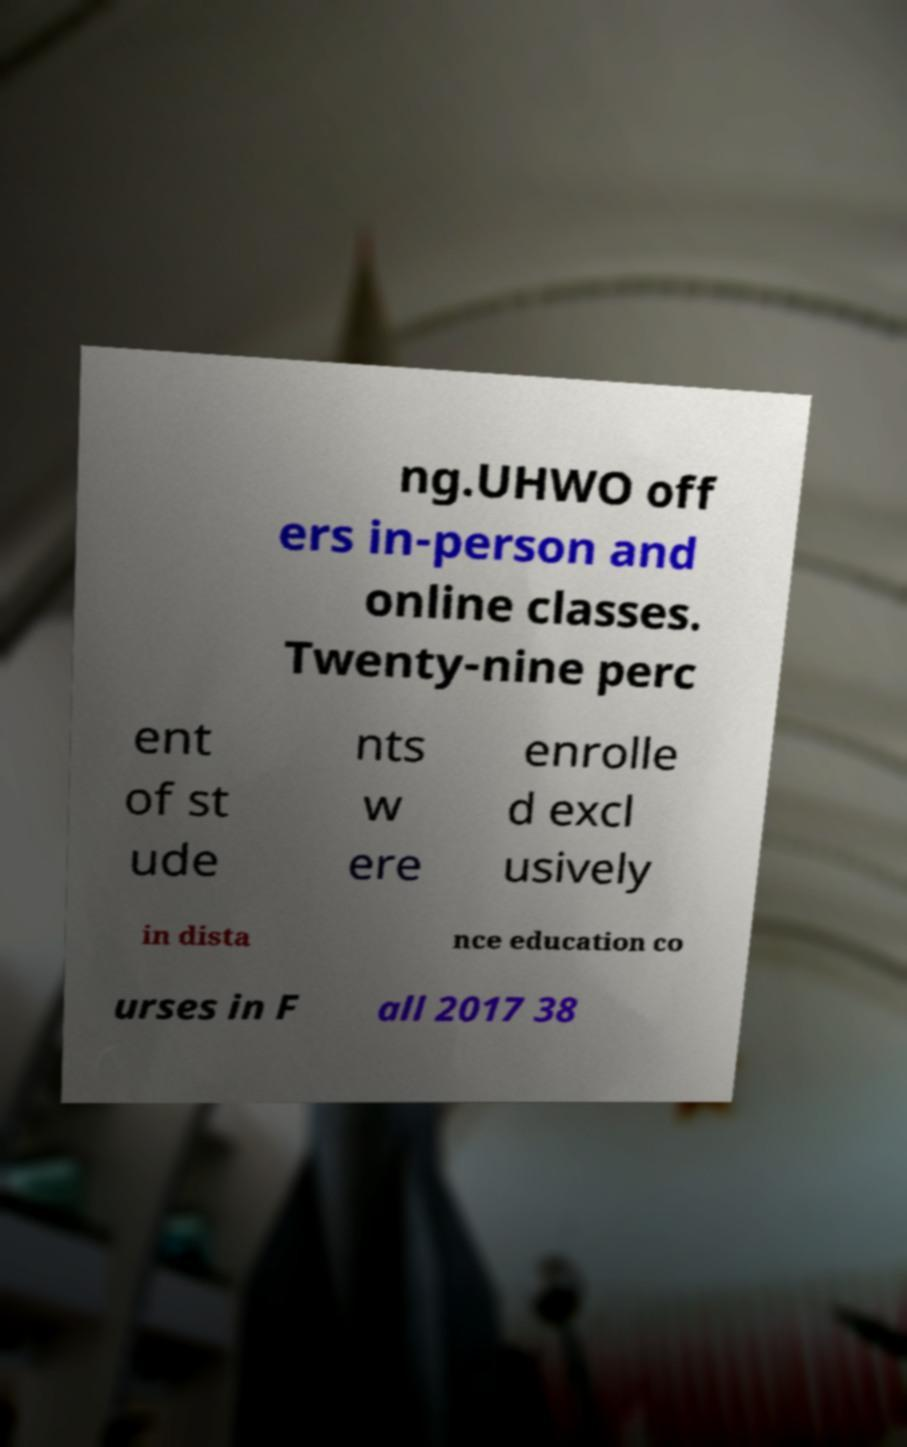Can you accurately transcribe the text from the provided image for me? ng.UHWO off ers in-person and online classes. Twenty-nine perc ent of st ude nts w ere enrolle d excl usively in dista nce education co urses in F all 2017 38 